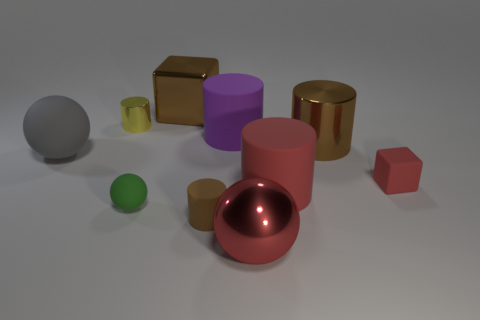Subtract all yellow cylinders. How many cylinders are left? 4 Subtract all large brown shiny cylinders. How many cylinders are left? 4 Subtract all green cylinders. Subtract all green spheres. How many cylinders are left? 5 Subtract all spheres. How many objects are left? 7 Add 3 green rubber spheres. How many green rubber spheres exist? 4 Subtract 0 purple cubes. How many objects are left? 10 Subtract all large blue shiny spheres. Subtract all tiny yellow cylinders. How many objects are left? 9 Add 4 yellow objects. How many yellow objects are left? 5 